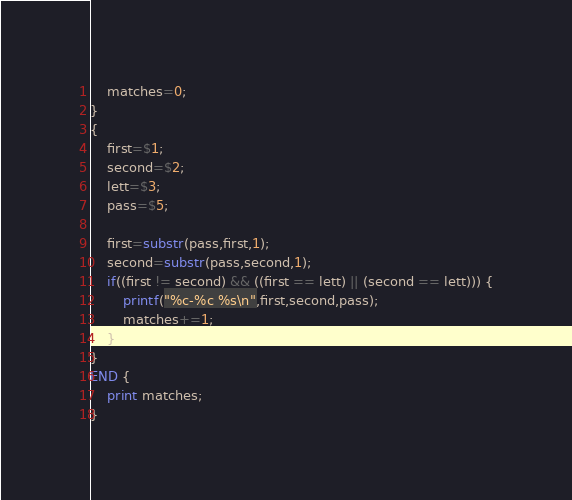<code> <loc_0><loc_0><loc_500><loc_500><_Awk_>	matches=0;
}
{
	first=$1;
	second=$2;
	lett=$3;
	pass=$5;
	
	first=substr(pass,first,1);
	second=substr(pass,second,1);
	if((first != second) && ((first == lett) || (second == lett))) {
		printf("%c-%c %s\n",first,second,pass);
		matches+=1;
	}	
}
END {
	print matches;
}
</code> 